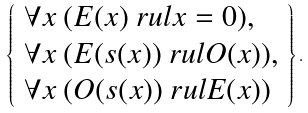Convert formula to latex. <formula><loc_0><loc_0><loc_500><loc_500>\left \{ \begin{array} { l } \forall x \ ( E ( x ) \ r u l x = 0 ) , \\ \forall x \ ( E ( s ( x ) ) \ r u l O ( x ) ) , \\ \forall x \ ( O ( s ( x ) ) \ r u l E ( x ) ) \end{array} \right \} .</formula> 